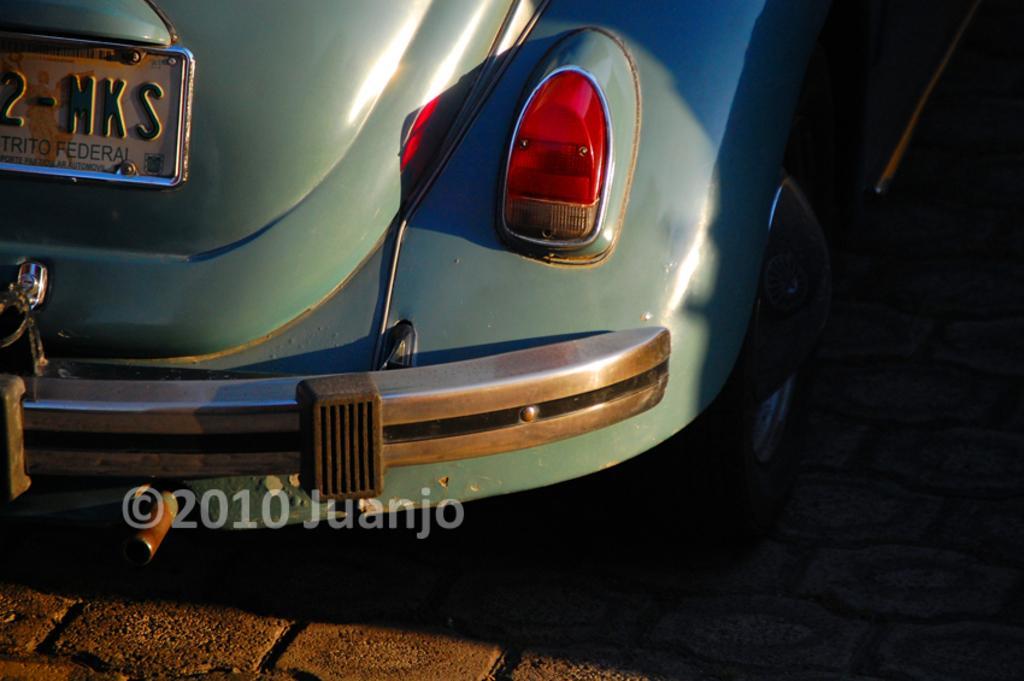Can you describe this image briefly? In this image I can see a car and on the top left side of the image I can see something is written on the board. I can also see a watermark on the bottom side of the image. 